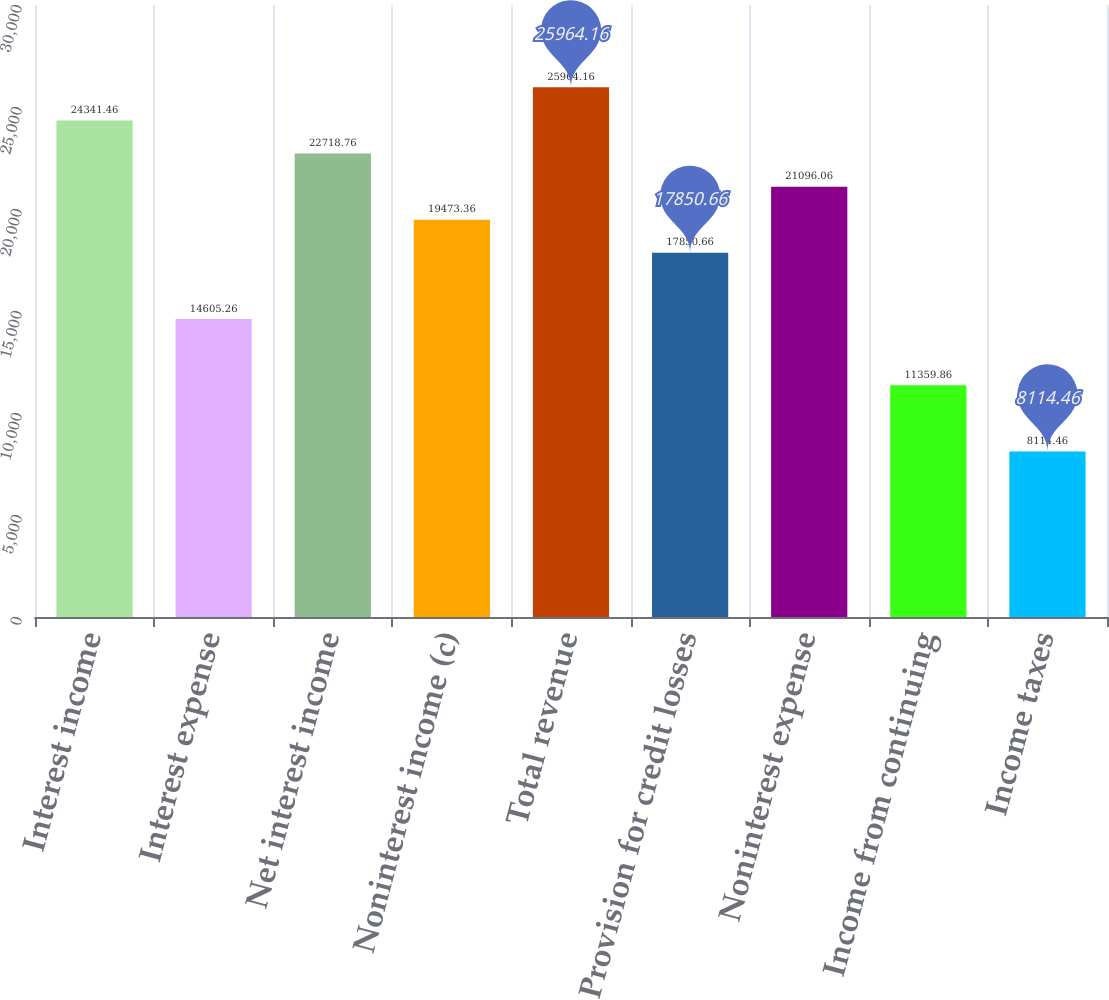<chart> <loc_0><loc_0><loc_500><loc_500><bar_chart><fcel>Interest income<fcel>Interest expense<fcel>Net interest income<fcel>Noninterest income (c)<fcel>Total revenue<fcel>Provision for credit losses<fcel>Noninterest expense<fcel>Income from continuing<fcel>Income taxes<nl><fcel>24341.5<fcel>14605.3<fcel>22718.8<fcel>19473.4<fcel>25964.2<fcel>17850.7<fcel>21096.1<fcel>11359.9<fcel>8114.46<nl></chart> 